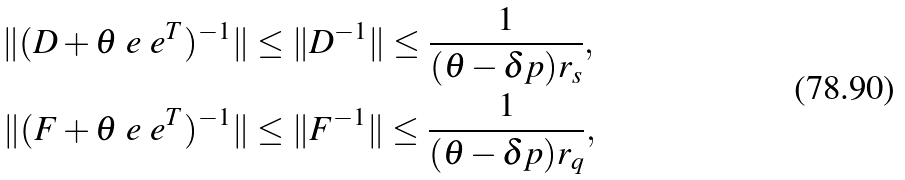Convert formula to latex. <formula><loc_0><loc_0><loc_500><loc_500>\| ( D + \theta \ e \ e ^ { T } ) ^ { - 1 } \| & \leq \| D ^ { - 1 } \| \leq \frac { 1 } { ( \theta - \delta p ) r _ { s } } , \\ \| ( F + \theta \ e \ e ^ { T } ) ^ { - 1 } \| & \leq \| F ^ { - 1 } \| \leq \frac { 1 } { ( \theta - \delta p ) r _ { q } } ,</formula> 